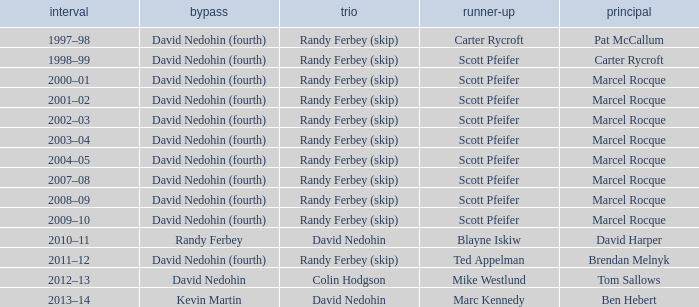Which Lead has a Third of randy ferbey (skip), a Second of scott pfeifer, and a Season of 2009–10? Marcel Rocque. 